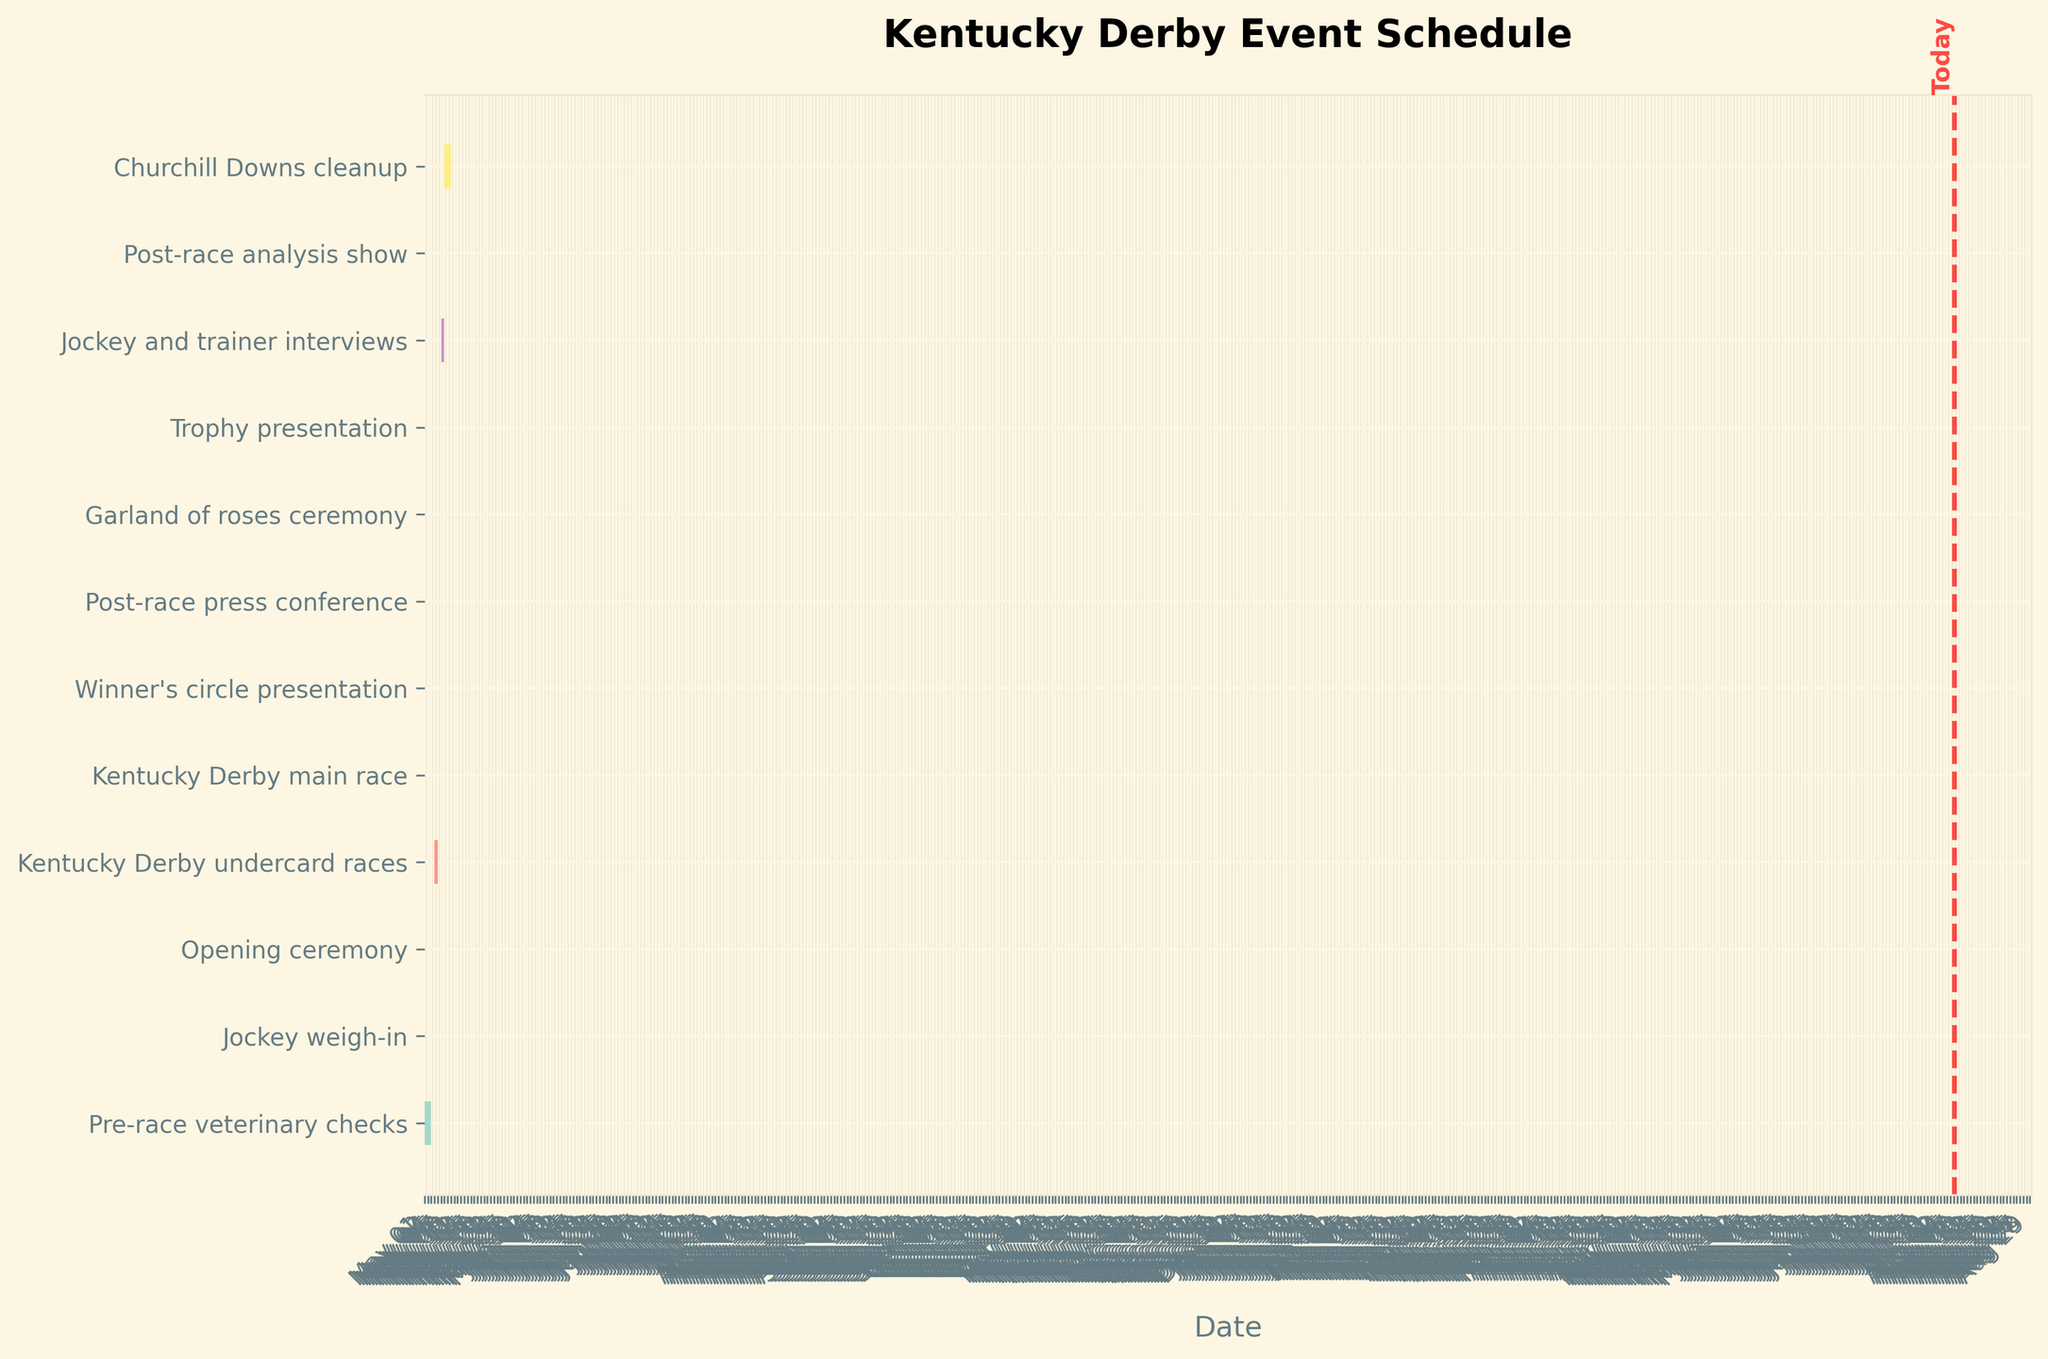When does the Pre-race veterinary checks begin and end? According to the Gantt chart, the Pre-race veterinary checks start on May 1, 2023, and end on May 3, 2023
Answer: May 1 - May 3, 2023 What event is scheduled to occur right after the Kentucky Derby main race? The Gantt chart shows that multiple events occur on May 6, 2023, right after the Kentucky Derby main race, including the Winner's circle presentation, the Post-race press conference, the Garland of roses ceremony, and the Trophy presentation
Answer: Winner's circle, Post-race press conference, Garland of roses, Trophy presentation How long is Churchill Downs cleanup scheduled to take? The Gantt chart shows that Churchill Downs cleanup starts on May 7, 2023, and ends on May 9, 2023. The duration can be calculated by finding the difference between the two dates: May 9 minus May 7 equals 2 days
Answer: 2 days Which event has the shortest duration? By looking at the Gantt chart, the event with the shortest duration is the Jockey weigh-in, which takes place only on May 4, 2023, lasting for just one day
Answer: Jockey weigh-in Are there any events scheduled on May 5, 2023? According to the Gantt chart, the Kentucky Derby undercard races are scheduled on May 5, 2023
Answer: Kentucky Derby undercard races How many events are scheduled to take place on May 6, 2023? Based on the Gantt chart, five events are planned for May 6, 2023: Kentucky Derby main race, Winner's circle presentation, Post-race press conference, Garland of roses ceremony, and Trophy presentation
Answer: 5 events What pre-race activities are scheduled before May 4, 2023? By inspecting the Gantt chart, the Pre-race veterinary checks are scheduled from May 1, 2023, to May 3, 2023, which are the pre-race activities before May 4, 2023
Answer: Pre-race veterinary checks How many days after the Kentucky Derby main race does the Churchill Downs cleanup end? The Kentucky Derby main race is on May 6, 2023, and Churchill Downs cleanup ends on May 9, 2023. By calculating the difference: May 9 minus May 6 equals 3 days
Answer: 3 days Which event out of the opening ceremony and the post-race press conference lasts longer? From the Gantt chart, the opening ceremony on May 4, 2023, lasts one day while the post-race press conference on May 6, 2023, also lasts one day. Both are of the same duration
Answer: Same duration 